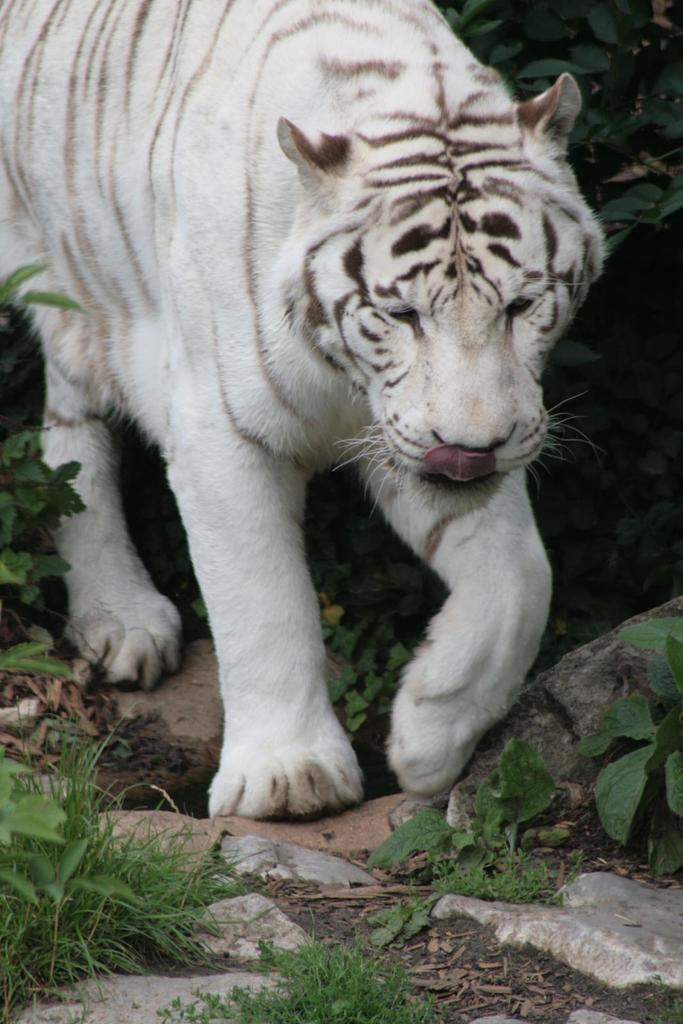Could you give a brief overview of what you see in this image? In this image we can see a white tiger on the ground. We can also see some stones, grass and some plants. 